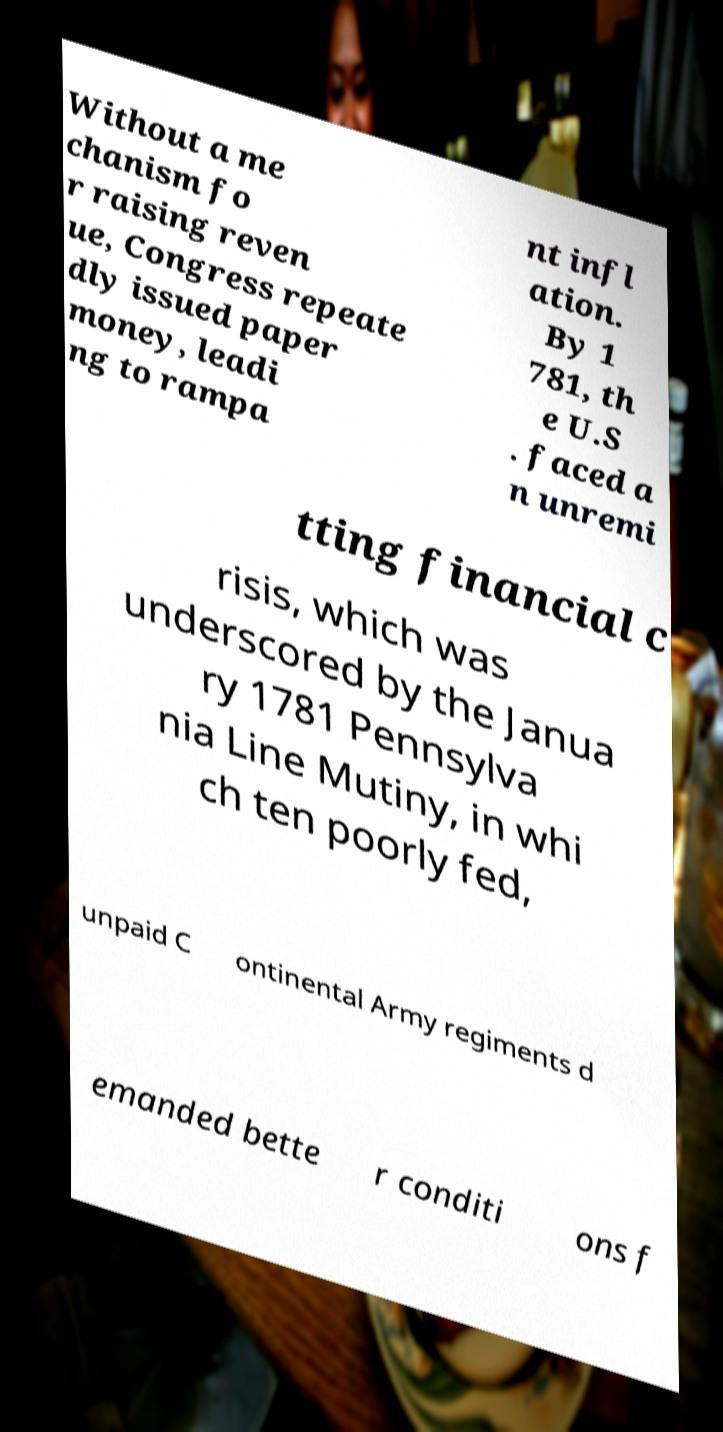There's text embedded in this image that I need extracted. Can you transcribe it verbatim? Without a me chanism fo r raising reven ue, Congress repeate dly issued paper money, leadi ng to rampa nt infl ation. By 1 781, th e U.S . faced a n unremi tting financial c risis, which was underscored by the Janua ry 1781 Pennsylva nia Line Mutiny, in whi ch ten poorly fed, unpaid C ontinental Army regiments d emanded bette r conditi ons f 